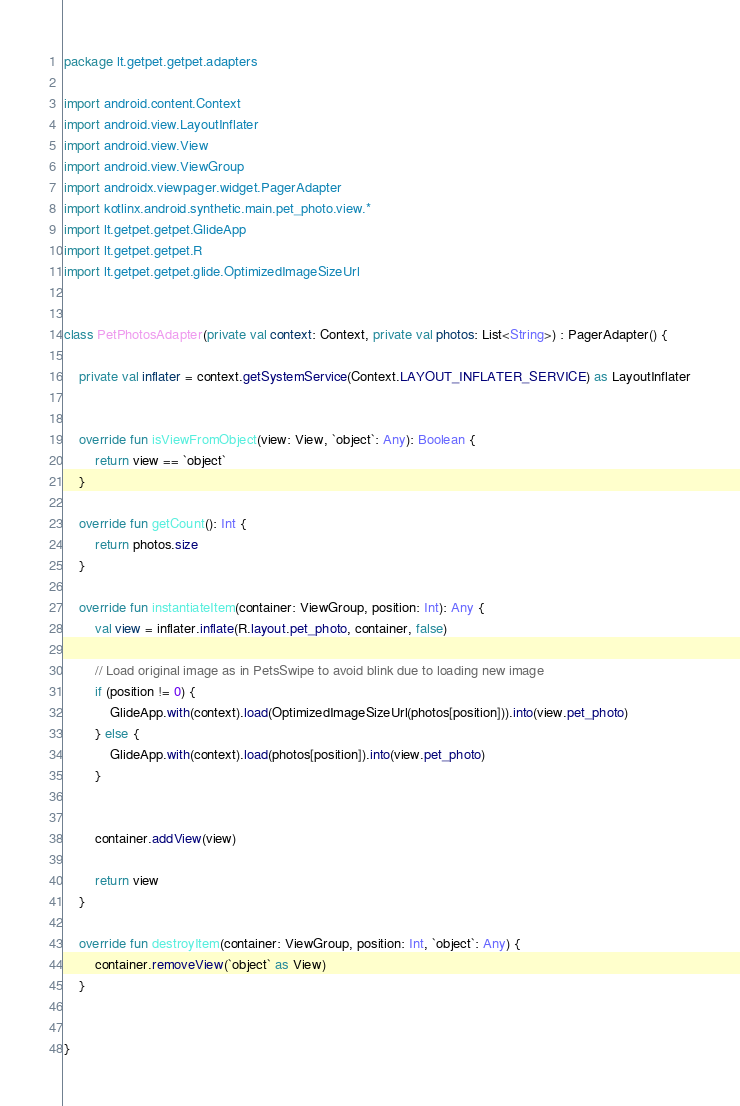Convert code to text. <code><loc_0><loc_0><loc_500><loc_500><_Kotlin_>package lt.getpet.getpet.adapters

import android.content.Context
import android.view.LayoutInflater
import android.view.View
import android.view.ViewGroup
import androidx.viewpager.widget.PagerAdapter
import kotlinx.android.synthetic.main.pet_photo.view.*
import lt.getpet.getpet.GlideApp
import lt.getpet.getpet.R
import lt.getpet.getpet.glide.OptimizedImageSizeUrl


class PetPhotosAdapter(private val context: Context, private val photos: List<String>) : PagerAdapter() {

    private val inflater = context.getSystemService(Context.LAYOUT_INFLATER_SERVICE) as LayoutInflater


    override fun isViewFromObject(view: View, `object`: Any): Boolean {
        return view == `object`
    }

    override fun getCount(): Int {
        return photos.size
    }

    override fun instantiateItem(container: ViewGroup, position: Int): Any {
        val view = inflater.inflate(R.layout.pet_photo, container, false)

        // Load original image as in PetsSwipe to avoid blink due to loading new image
        if (position != 0) {
            GlideApp.with(context).load(OptimizedImageSizeUrl(photos[position])).into(view.pet_photo)
        } else {
            GlideApp.with(context).load(photos[position]).into(view.pet_photo)
        }


        container.addView(view)

        return view
    }

    override fun destroyItem(container: ViewGroup, position: Int, `object`: Any) {
        container.removeView(`object` as View)
    }


}</code> 